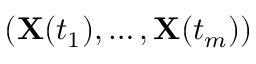Convert formula to latex. <formula><loc_0><loc_0><loc_500><loc_500>( X ( t _ { 1 } ) , \dots , X ( t _ { m } ) )</formula> 